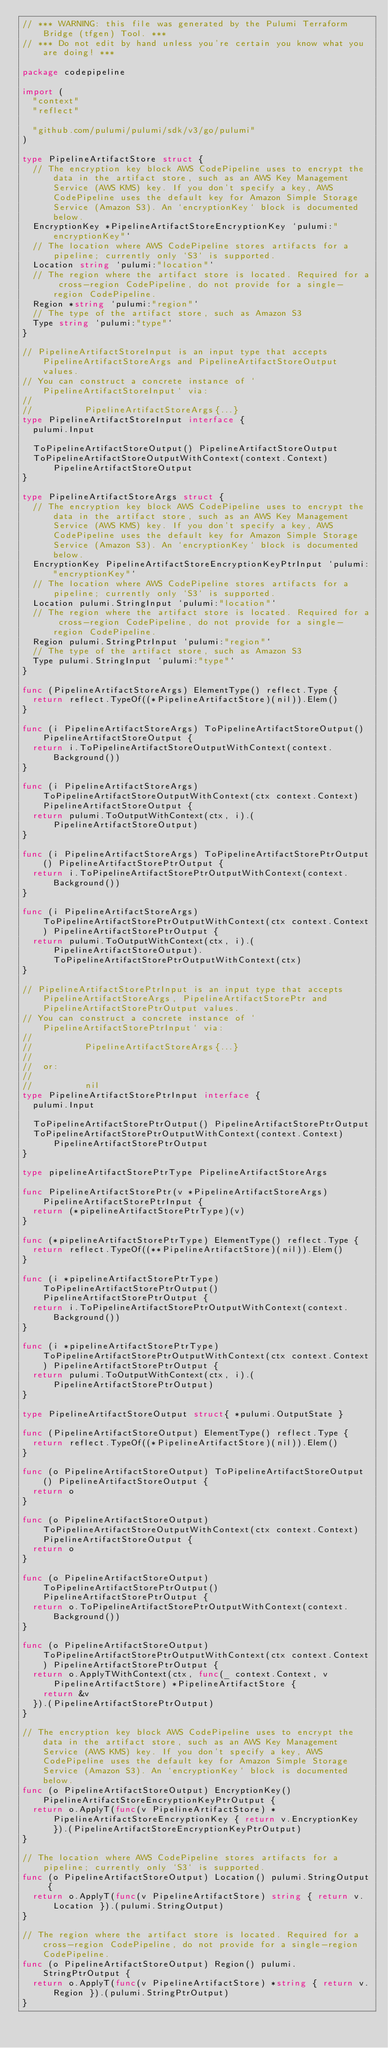Convert code to text. <code><loc_0><loc_0><loc_500><loc_500><_Go_>// *** WARNING: this file was generated by the Pulumi Terraform Bridge (tfgen) Tool. ***
// *** Do not edit by hand unless you're certain you know what you are doing! ***

package codepipeline

import (
	"context"
	"reflect"

	"github.com/pulumi/pulumi/sdk/v3/go/pulumi"
)

type PipelineArtifactStore struct {
	// The encryption key block AWS CodePipeline uses to encrypt the data in the artifact store, such as an AWS Key Management Service (AWS KMS) key. If you don't specify a key, AWS CodePipeline uses the default key for Amazon Simple Storage Service (Amazon S3). An `encryptionKey` block is documented below.
	EncryptionKey *PipelineArtifactStoreEncryptionKey `pulumi:"encryptionKey"`
	// The location where AWS CodePipeline stores artifacts for a pipeline; currently only `S3` is supported.
	Location string `pulumi:"location"`
	// The region where the artifact store is located. Required for a cross-region CodePipeline, do not provide for a single-region CodePipeline.
	Region *string `pulumi:"region"`
	// The type of the artifact store, such as Amazon S3
	Type string `pulumi:"type"`
}

// PipelineArtifactStoreInput is an input type that accepts PipelineArtifactStoreArgs and PipelineArtifactStoreOutput values.
// You can construct a concrete instance of `PipelineArtifactStoreInput` via:
//
//          PipelineArtifactStoreArgs{...}
type PipelineArtifactStoreInput interface {
	pulumi.Input

	ToPipelineArtifactStoreOutput() PipelineArtifactStoreOutput
	ToPipelineArtifactStoreOutputWithContext(context.Context) PipelineArtifactStoreOutput
}

type PipelineArtifactStoreArgs struct {
	// The encryption key block AWS CodePipeline uses to encrypt the data in the artifact store, such as an AWS Key Management Service (AWS KMS) key. If you don't specify a key, AWS CodePipeline uses the default key for Amazon Simple Storage Service (Amazon S3). An `encryptionKey` block is documented below.
	EncryptionKey PipelineArtifactStoreEncryptionKeyPtrInput `pulumi:"encryptionKey"`
	// The location where AWS CodePipeline stores artifacts for a pipeline; currently only `S3` is supported.
	Location pulumi.StringInput `pulumi:"location"`
	// The region where the artifact store is located. Required for a cross-region CodePipeline, do not provide for a single-region CodePipeline.
	Region pulumi.StringPtrInput `pulumi:"region"`
	// The type of the artifact store, such as Amazon S3
	Type pulumi.StringInput `pulumi:"type"`
}

func (PipelineArtifactStoreArgs) ElementType() reflect.Type {
	return reflect.TypeOf((*PipelineArtifactStore)(nil)).Elem()
}

func (i PipelineArtifactStoreArgs) ToPipelineArtifactStoreOutput() PipelineArtifactStoreOutput {
	return i.ToPipelineArtifactStoreOutputWithContext(context.Background())
}

func (i PipelineArtifactStoreArgs) ToPipelineArtifactStoreOutputWithContext(ctx context.Context) PipelineArtifactStoreOutput {
	return pulumi.ToOutputWithContext(ctx, i).(PipelineArtifactStoreOutput)
}

func (i PipelineArtifactStoreArgs) ToPipelineArtifactStorePtrOutput() PipelineArtifactStorePtrOutput {
	return i.ToPipelineArtifactStorePtrOutputWithContext(context.Background())
}

func (i PipelineArtifactStoreArgs) ToPipelineArtifactStorePtrOutputWithContext(ctx context.Context) PipelineArtifactStorePtrOutput {
	return pulumi.ToOutputWithContext(ctx, i).(PipelineArtifactStoreOutput).ToPipelineArtifactStorePtrOutputWithContext(ctx)
}

// PipelineArtifactStorePtrInput is an input type that accepts PipelineArtifactStoreArgs, PipelineArtifactStorePtr and PipelineArtifactStorePtrOutput values.
// You can construct a concrete instance of `PipelineArtifactStorePtrInput` via:
//
//          PipelineArtifactStoreArgs{...}
//
//  or:
//
//          nil
type PipelineArtifactStorePtrInput interface {
	pulumi.Input

	ToPipelineArtifactStorePtrOutput() PipelineArtifactStorePtrOutput
	ToPipelineArtifactStorePtrOutputWithContext(context.Context) PipelineArtifactStorePtrOutput
}

type pipelineArtifactStorePtrType PipelineArtifactStoreArgs

func PipelineArtifactStorePtr(v *PipelineArtifactStoreArgs) PipelineArtifactStorePtrInput {
	return (*pipelineArtifactStorePtrType)(v)
}

func (*pipelineArtifactStorePtrType) ElementType() reflect.Type {
	return reflect.TypeOf((**PipelineArtifactStore)(nil)).Elem()
}

func (i *pipelineArtifactStorePtrType) ToPipelineArtifactStorePtrOutput() PipelineArtifactStorePtrOutput {
	return i.ToPipelineArtifactStorePtrOutputWithContext(context.Background())
}

func (i *pipelineArtifactStorePtrType) ToPipelineArtifactStorePtrOutputWithContext(ctx context.Context) PipelineArtifactStorePtrOutput {
	return pulumi.ToOutputWithContext(ctx, i).(PipelineArtifactStorePtrOutput)
}

type PipelineArtifactStoreOutput struct{ *pulumi.OutputState }

func (PipelineArtifactStoreOutput) ElementType() reflect.Type {
	return reflect.TypeOf((*PipelineArtifactStore)(nil)).Elem()
}

func (o PipelineArtifactStoreOutput) ToPipelineArtifactStoreOutput() PipelineArtifactStoreOutput {
	return o
}

func (o PipelineArtifactStoreOutput) ToPipelineArtifactStoreOutputWithContext(ctx context.Context) PipelineArtifactStoreOutput {
	return o
}

func (o PipelineArtifactStoreOutput) ToPipelineArtifactStorePtrOutput() PipelineArtifactStorePtrOutput {
	return o.ToPipelineArtifactStorePtrOutputWithContext(context.Background())
}

func (o PipelineArtifactStoreOutput) ToPipelineArtifactStorePtrOutputWithContext(ctx context.Context) PipelineArtifactStorePtrOutput {
	return o.ApplyTWithContext(ctx, func(_ context.Context, v PipelineArtifactStore) *PipelineArtifactStore {
		return &v
	}).(PipelineArtifactStorePtrOutput)
}

// The encryption key block AWS CodePipeline uses to encrypt the data in the artifact store, such as an AWS Key Management Service (AWS KMS) key. If you don't specify a key, AWS CodePipeline uses the default key for Amazon Simple Storage Service (Amazon S3). An `encryptionKey` block is documented below.
func (o PipelineArtifactStoreOutput) EncryptionKey() PipelineArtifactStoreEncryptionKeyPtrOutput {
	return o.ApplyT(func(v PipelineArtifactStore) *PipelineArtifactStoreEncryptionKey { return v.EncryptionKey }).(PipelineArtifactStoreEncryptionKeyPtrOutput)
}

// The location where AWS CodePipeline stores artifacts for a pipeline; currently only `S3` is supported.
func (o PipelineArtifactStoreOutput) Location() pulumi.StringOutput {
	return o.ApplyT(func(v PipelineArtifactStore) string { return v.Location }).(pulumi.StringOutput)
}

// The region where the artifact store is located. Required for a cross-region CodePipeline, do not provide for a single-region CodePipeline.
func (o PipelineArtifactStoreOutput) Region() pulumi.StringPtrOutput {
	return o.ApplyT(func(v PipelineArtifactStore) *string { return v.Region }).(pulumi.StringPtrOutput)
}
</code> 